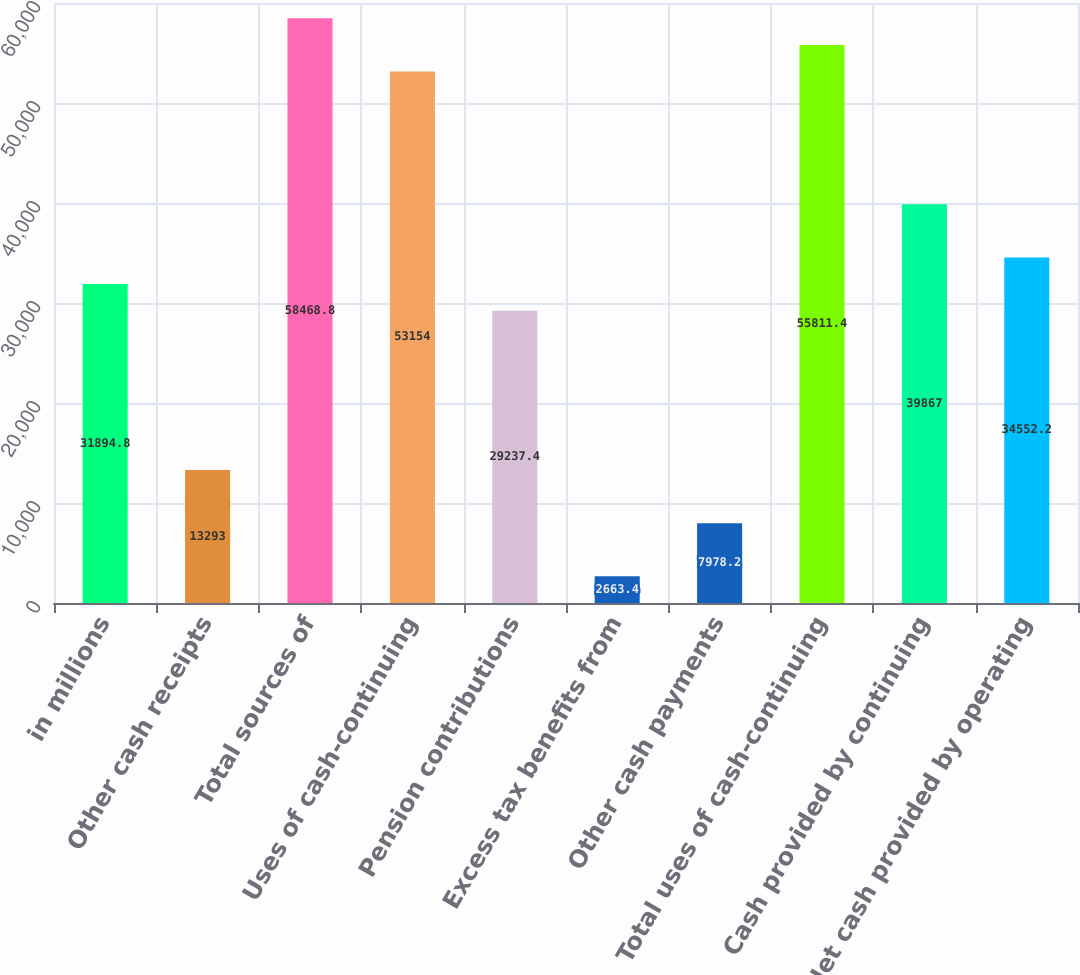Convert chart. <chart><loc_0><loc_0><loc_500><loc_500><bar_chart><fcel>in millions<fcel>Other cash receipts<fcel>Total sources of<fcel>Uses of cash-continuing<fcel>Pension contributions<fcel>Excess tax benefits from<fcel>Other cash payments<fcel>Total uses of cash-continuing<fcel>Cash provided by continuing<fcel>Net cash provided by operating<nl><fcel>31894.8<fcel>13293<fcel>58468.8<fcel>53154<fcel>29237.4<fcel>2663.4<fcel>7978.2<fcel>55811.4<fcel>39867<fcel>34552.2<nl></chart> 